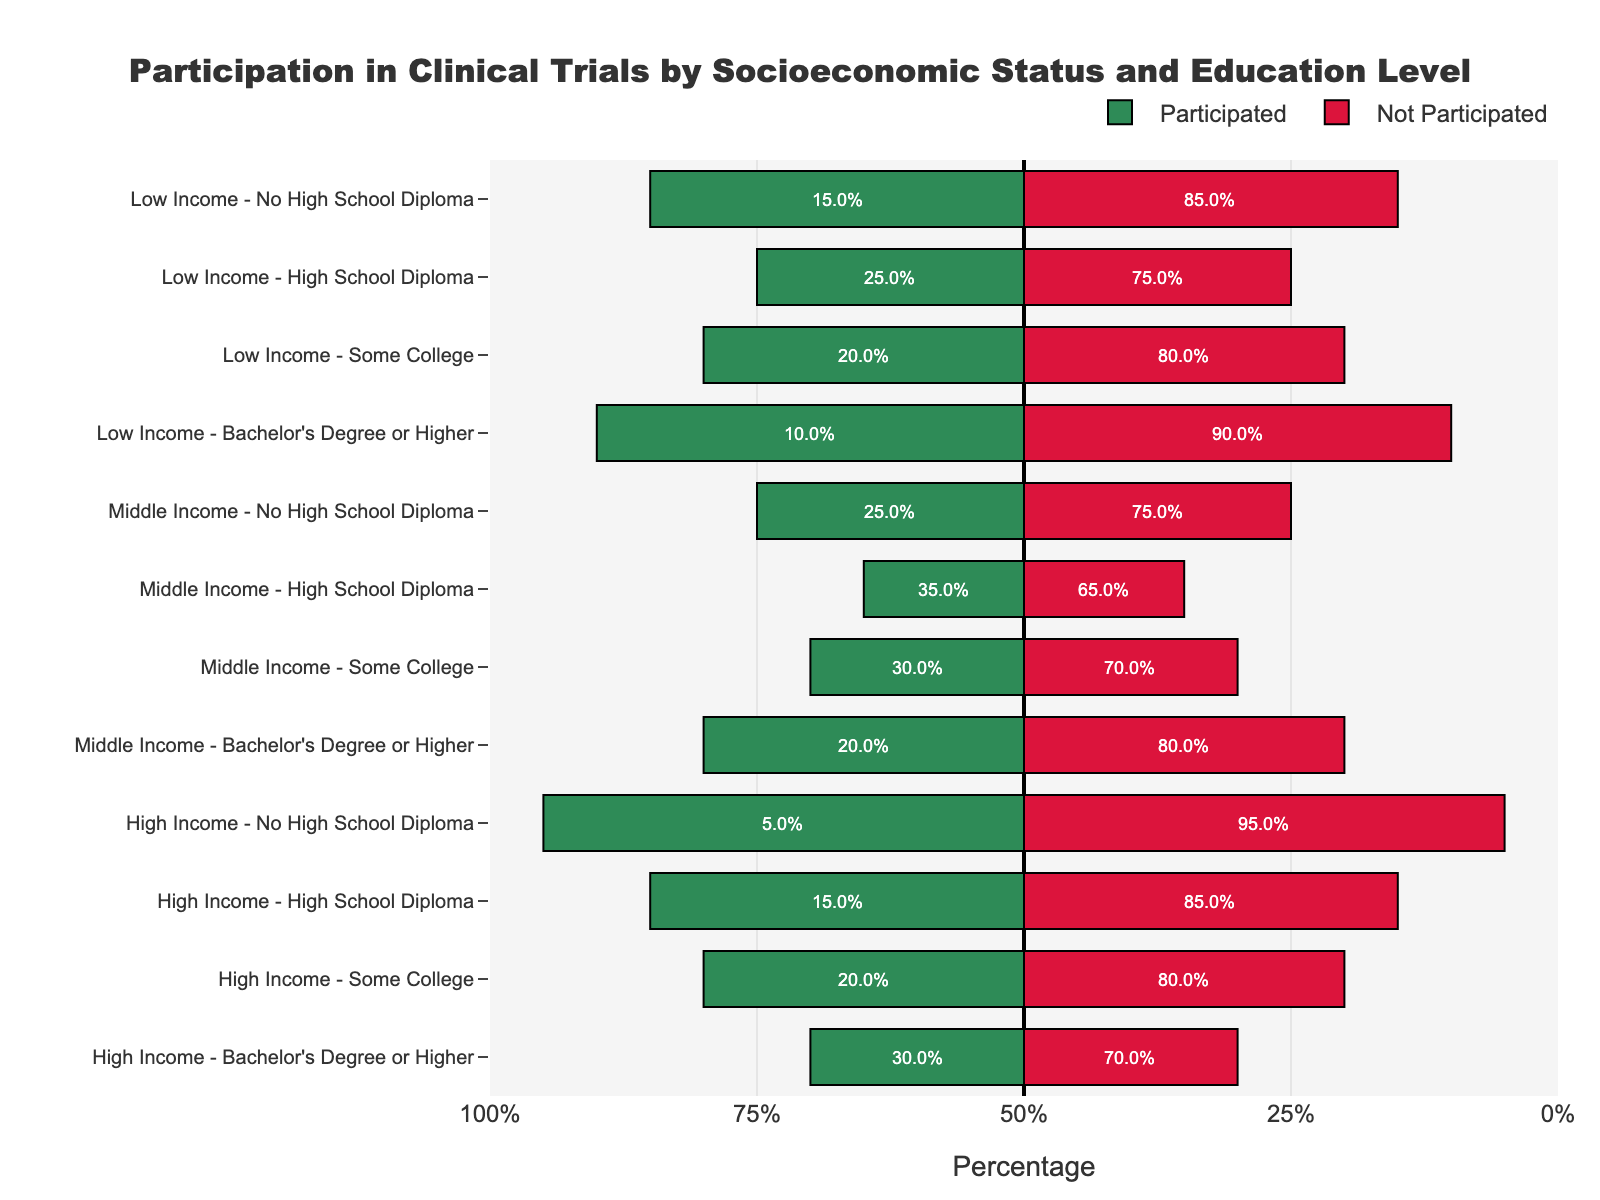Which education level within the low-income group has the highest participation in clinical trials? Look at the different bars for the low-income group and identify which education level has the longest green bar (indicating the highest participation percentage). The high school diploma subgroup has the longest green bar.
Answer: High School Diploma How does the participation rate of low-income individuals with some college compare to that of high-income individuals with a bachelor's degree or higher? Compare the length of the green bars for low-income individuals with some college to high-income individuals with a bachelor's degree or higher. Low-income individuals with some college have a shorter green bar compared to high-income individuals with a bachelor's degree or higher.
Answer: Lower What is the percentage of middle-income individuals without a high school diploma who did not participate in clinical trials? Look at the red bar for the middle-income group without a high school diploma and read off the percentage labeled in the bar. The red bar is 75%, indicating that 75% did not participate.
Answer: 75% Which socioeconomic group has the lowest participation in clinical trials for those with a bachelor's degree or higher? Compare the green bars for the different socioeconomic groups with a bachelor's degree or higher. The low-income group has the shortest green bar.
Answer: Low Income What is the total non-participation rate for high-income individuals across all education levels? Sum up the percentages of the red bars for all education levels within the high-income group. The percentages are 95% (No High School Diploma) + 85% (High School Diploma) + 80% (Some College) + 70% (Bachelor's Degree or Higher). Calculating the total: 95 + 85 + 80 + 70 = 330%.
Answer: 330% Which group and education level have the highest difference in participation vs. non-participation rates? Calculate the difference between participation and non-participation percentages for each group and education level. The largest difference is for low-income individuals with no high school diploma (85% non-participated - 15% participated = 70%).
Answer: Low Income, No High School Diploma What is the average participation rate across all education levels within the middle-income group? Calculate the average by summing the participation percentages of the middle-income group across all education levels and then dividing by the number of education levels. The participation percentages are 25% (No High School Diploma) + 35% (High School Diploma) + 30% (Some College) + 20% (Bachelor's Degree or Higher). Calculating the average: (25 + 35 + 30 + 20) / 4 = 27.5%.
Answer: 27.5% Does having a high school diploma affect participation rates differently in low-income vs. high-income groups? Compare the green bars for individuals with a high school diploma in both low-income and high-income groups. The low-income group shows 25% while the high-income group shows 15%, indicating a higher rate of participation among low-income individuals with a high school diploma.
Answer: Yes, higher in low income 